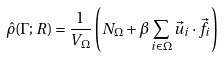Convert formula to latex. <formula><loc_0><loc_0><loc_500><loc_500>\hat { \rho } ( \Gamma ; R ) = \frac { 1 } { V _ { \Omega } } \left ( N _ { \Omega } + \beta \sum _ { i \in \Omega } \vec { u } _ { i } \cdot \vec { f } _ { i } \right )</formula> 